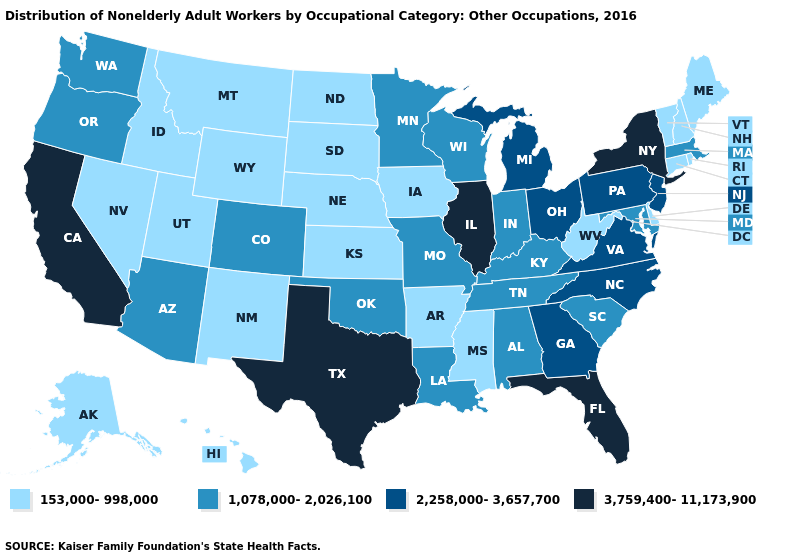Does North Carolina have a lower value than Tennessee?
Give a very brief answer. No. Does Missouri have the lowest value in the MidWest?
Keep it brief. No. How many symbols are there in the legend?
Short answer required. 4. Is the legend a continuous bar?
Concise answer only. No. What is the highest value in the MidWest ?
Short answer required. 3,759,400-11,173,900. How many symbols are there in the legend?
Be succinct. 4. What is the lowest value in the West?
Answer briefly. 153,000-998,000. What is the value of Mississippi?
Answer briefly. 153,000-998,000. Name the states that have a value in the range 2,258,000-3,657,700?
Quick response, please. Georgia, Michigan, New Jersey, North Carolina, Ohio, Pennsylvania, Virginia. What is the highest value in the West ?
Short answer required. 3,759,400-11,173,900. Does North Carolina have the same value as New Jersey?
Quick response, please. Yes. Name the states that have a value in the range 1,078,000-2,026,100?
Write a very short answer. Alabama, Arizona, Colorado, Indiana, Kentucky, Louisiana, Maryland, Massachusetts, Minnesota, Missouri, Oklahoma, Oregon, South Carolina, Tennessee, Washington, Wisconsin. What is the value of Louisiana?
Give a very brief answer. 1,078,000-2,026,100. Does Minnesota have a lower value than Rhode Island?
Be succinct. No. What is the value of Pennsylvania?
Keep it brief. 2,258,000-3,657,700. 